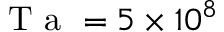Convert formula to latex. <formula><loc_0><loc_0><loc_500><loc_500>T a = 5 \times 1 0 ^ { 8 }</formula> 